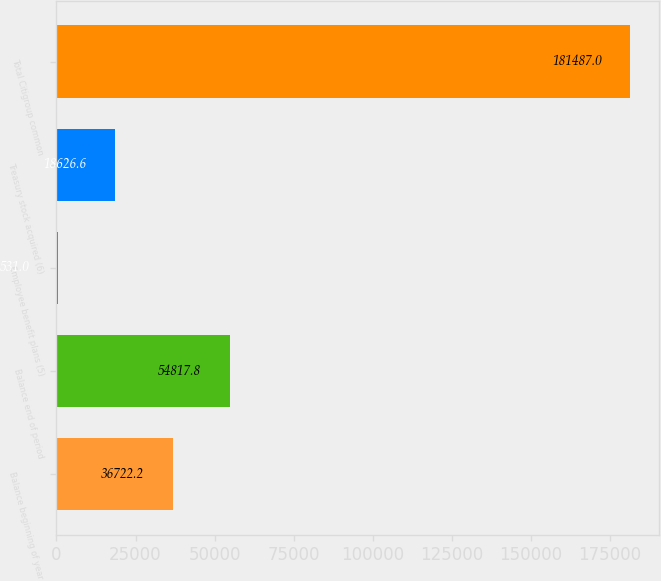<chart> <loc_0><loc_0><loc_500><loc_500><bar_chart><fcel>Balance beginning of year<fcel>Balance end of period<fcel>Employee benefit plans (5)<fcel>Treasury stock acquired (6)<fcel>Total Citigroup common<nl><fcel>36722.2<fcel>54817.8<fcel>531<fcel>18626.6<fcel>181487<nl></chart> 